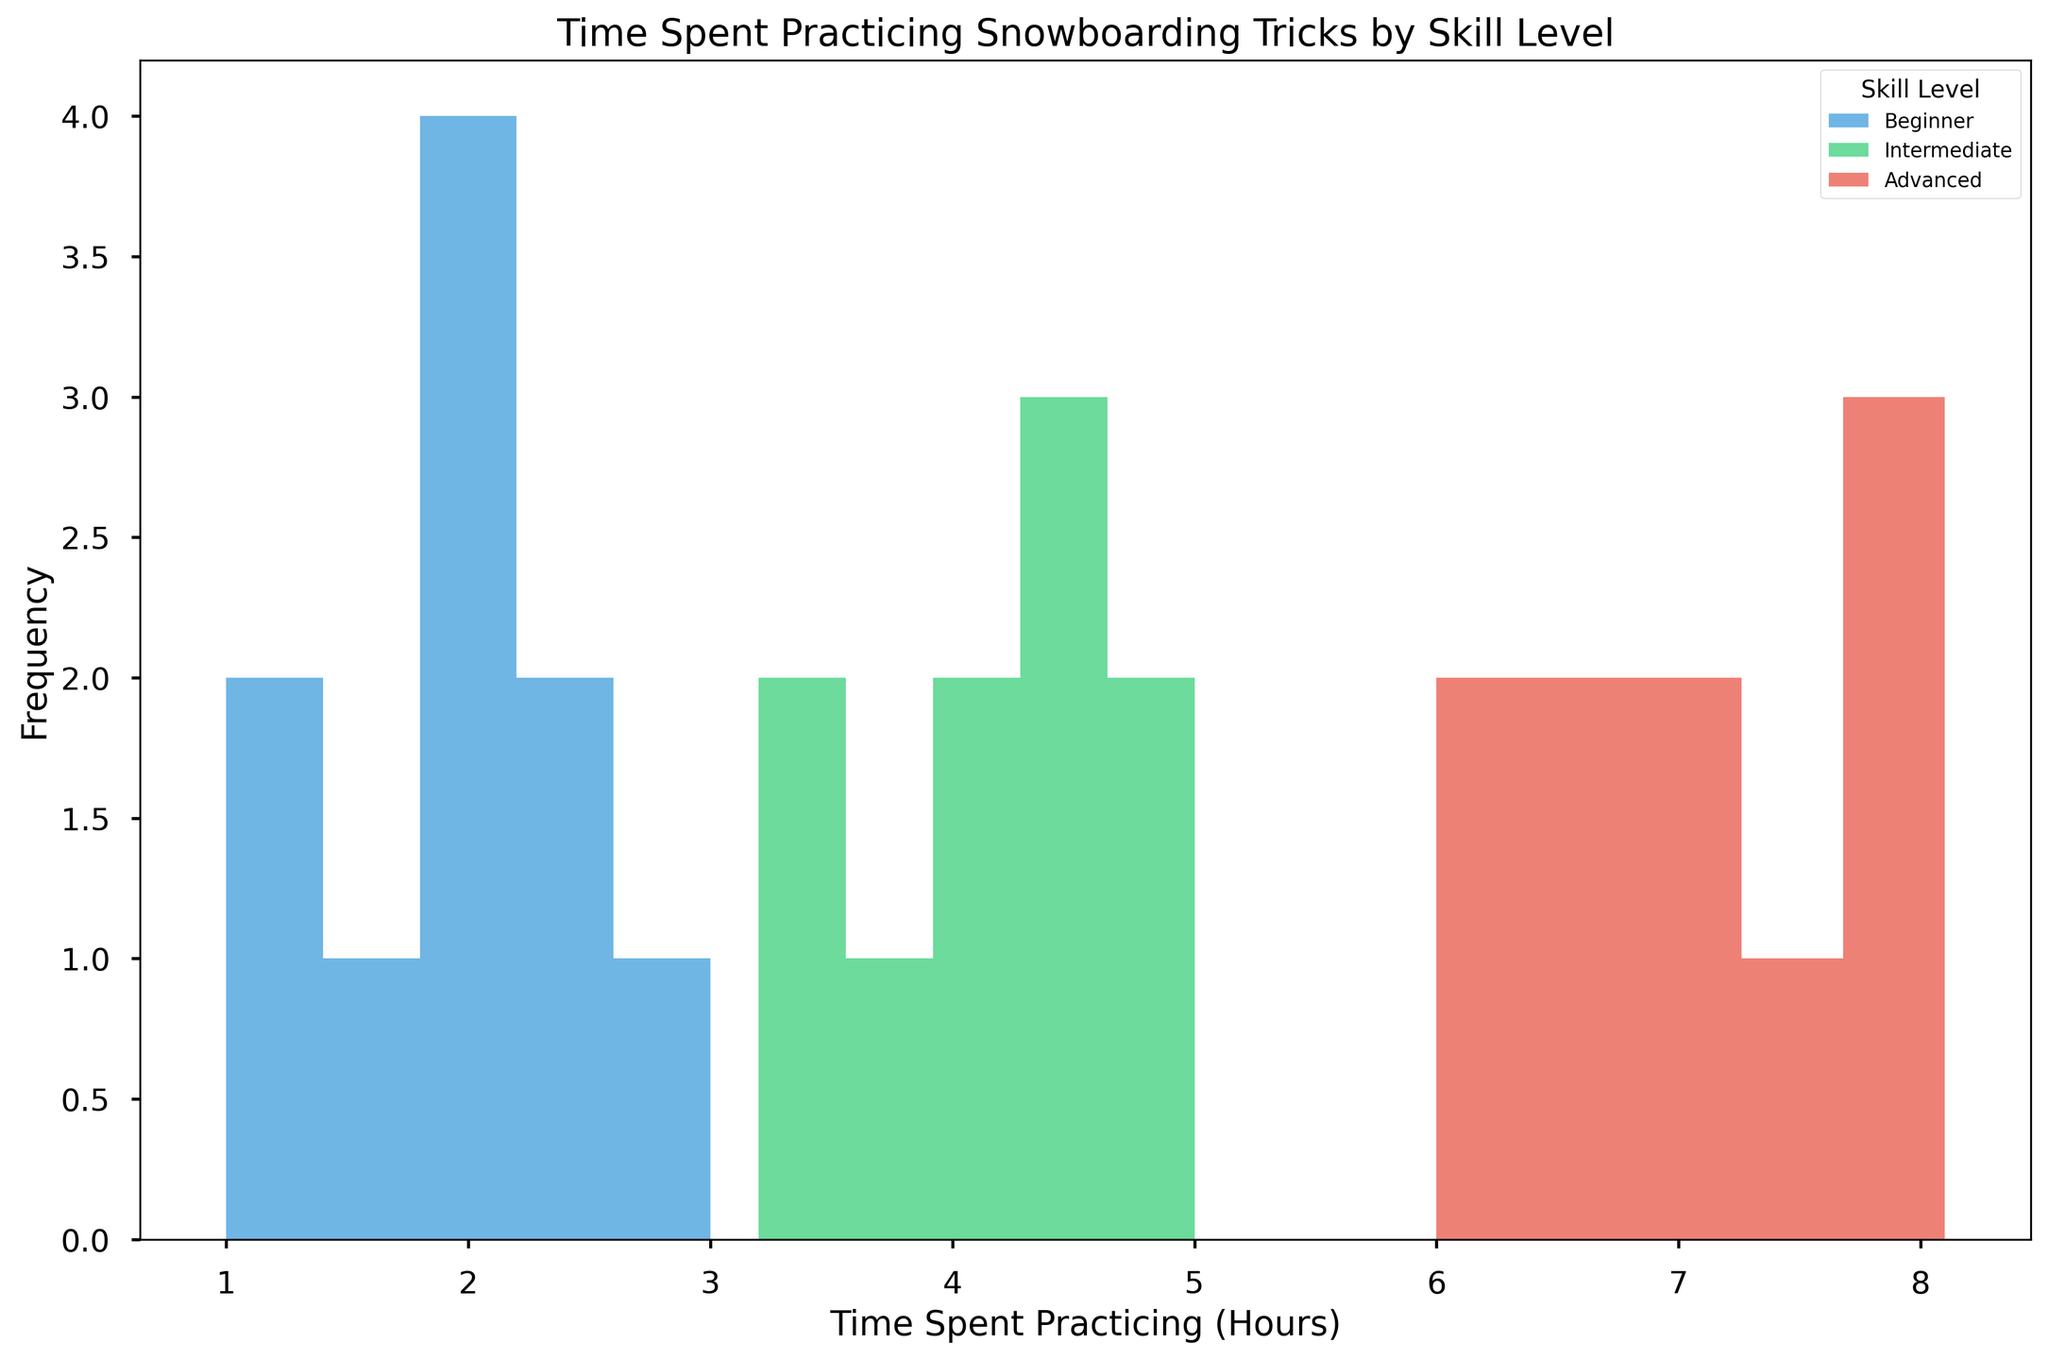What are the three skill levels represented in the histogram? The skill levels are listed in the legend, which shows three distinct labels. Look at the labels in the legend section of the histogram.
Answer: Beginner, Intermediate, Advanced Which skill level spends the most time practicing snowboarding tricks on average? Examine the peaks of the histograms for each skill level. The advanced level has the highest peaks at higher time intervals (e.g., 6+ hours). This means advanced practitioners spend more time on average.
Answer: Advanced What is the range of time spent practicing for intermediate snowboarders? Look at the leftmost and rightmost bars of the intermediate skill level (green). The bars span from 3.2 to 5 hours.
Answer: 3.2 to 5 hours Which skill level shows the largest variation in practicing hours? Compare the width and spread of the bars for each skill level. The advanced level (red) covers a wide range from 6 to 8.1 hours, suggesting greater variation.
Answer: Advanced How many bins were used for each skill level in the histogram? Count the number of distinct bars for any one skill level in the histogram. Each skill level has 5 bins as there are 5 bars for each.
Answer: 5 For which skill level is the practicing time most concentrated around a specific value? Look at the width and grouping of the bars. The beginner group (blue) has most values concentrated around the 2-hour mark.
Answer: Beginner What is the most frequent practicing time range for beginners? Find the tallest bar in the beginner group (blue). The tallest bar is the one representing the 1.5-2 hour range, indicating the most frequent practicing time.
Answer: 1.5-2 hours Based on the histogram, which level is more likely to practice for 4 hours? Look at the bars near 4 hours for each skill level. The intermediate level (green) has a significant peak around 4 hours, indicating it's more likely for them to practice around this duration.
Answer: Intermediate 